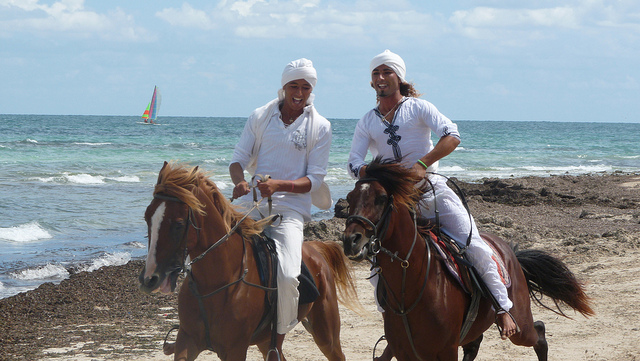Describe the mood and atmosphere of the scene. The scene exudes a joyful and relaxed atmosphere. The two riders appear to be in high spirits, enjoying a leisurely ride along the beach. The calm ocean waves and the bright, sunny day contribute to a sense of tranquility and contentment. 